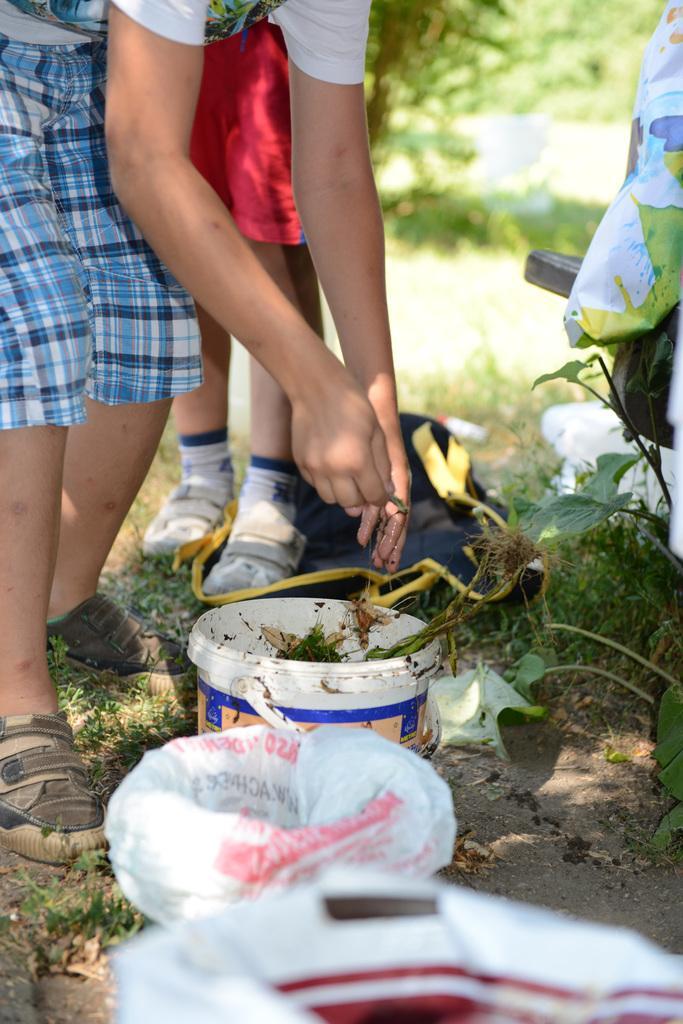Please provide a concise description of this image. In this image I can see a person holding something. We can see buckets and plastic covers. I can see plants and grass. 